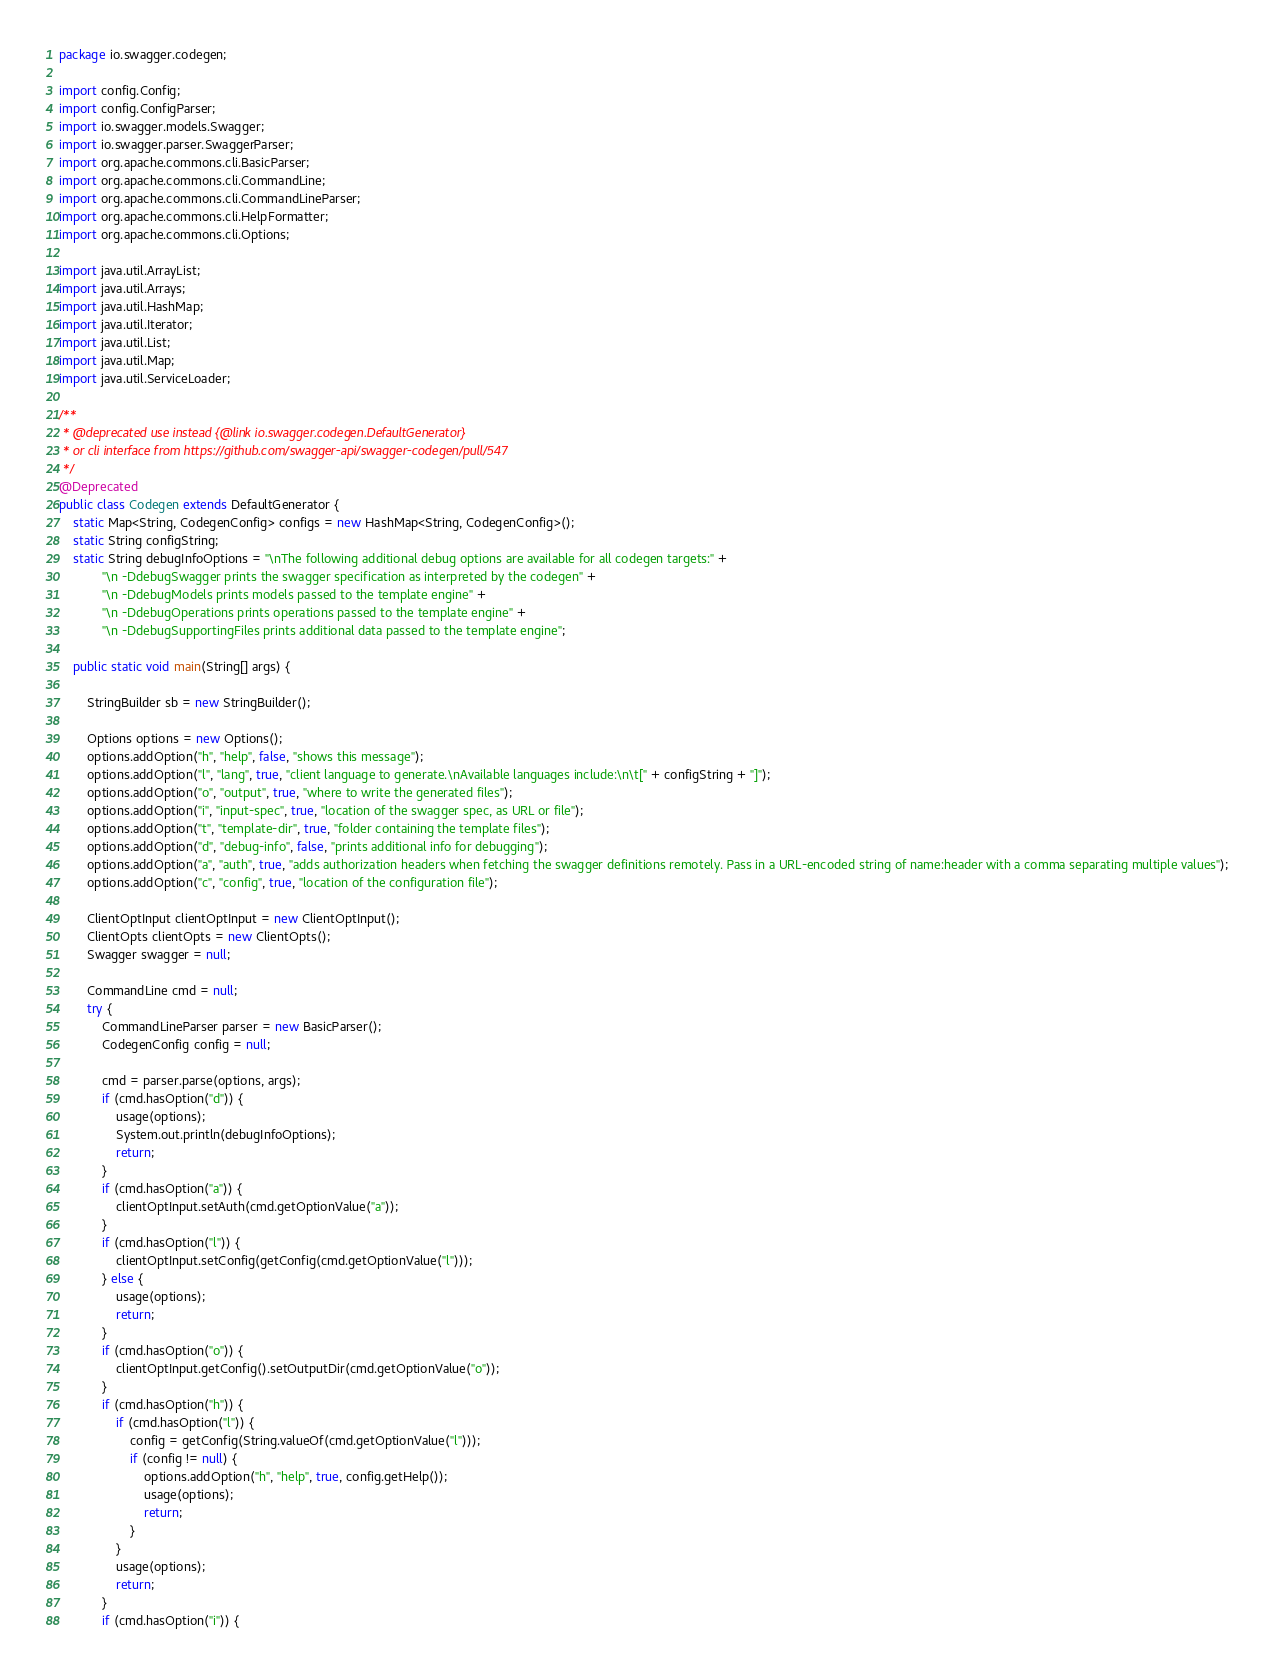Convert code to text. <code><loc_0><loc_0><loc_500><loc_500><_Java_>package io.swagger.codegen;

import config.Config;
import config.ConfigParser;
import io.swagger.models.Swagger;
import io.swagger.parser.SwaggerParser;
import org.apache.commons.cli.BasicParser;
import org.apache.commons.cli.CommandLine;
import org.apache.commons.cli.CommandLineParser;
import org.apache.commons.cli.HelpFormatter;
import org.apache.commons.cli.Options;

import java.util.ArrayList;
import java.util.Arrays;
import java.util.HashMap;
import java.util.Iterator;
import java.util.List;
import java.util.Map;
import java.util.ServiceLoader;

/**
 * @deprecated use instead {@link io.swagger.codegen.DefaultGenerator}
 * or cli interface from https://github.com/swagger-api/swagger-codegen/pull/547
 */
@Deprecated
public class Codegen extends DefaultGenerator {
    static Map<String, CodegenConfig> configs = new HashMap<String, CodegenConfig>();
    static String configString;
    static String debugInfoOptions = "\nThe following additional debug options are available for all codegen targets:" +
            "\n -DdebugSwagger prints the swagger specification as interpreted by the codegen" +
            "\n -DdebugModels prints models passed to the template engine" +
            "\n -DdebugOperations prints operations passed to the template engine" +
            "\n -DdebugSupportingFiles prints additional data passed to the template engine";

    public static void main(String[] args) {

        StringBuilder sb = new StringBuilder();

        Options options = new Options();
        options.addOption("h", "help", false, "shows this message");
        options.addOption("l", "lang", true, "client language to generate.\nAvailable languages include:\n\t[" + configString + "]");
        options.addOption("o", "output", true, "where to write the generated files");
        options.addOption("i", "input-spec", true, "location of the swagger spec, as URL or file");
        options.addOption("t", "template-dir", true, "folder containing the template files");
        options.addOption("d", "debug-info", false, "prints additional info for debugging");
        options.addOption("a", "auth", true, "adds authorization headers when fetching the swagger definitions remotely. Pass in a URL-encoded string of name:header with a comma separating multiple values");
        options.addOption("c", "config", true, "location of the configuration file");

        ClientOptInput clientOptInput = new ClientOptInput();
        ClientOpts clientOpts = new ClientOpts();
        Swagger swagger = null;

        CommandLine cmd = null;
        try {
            CommandLineParser parser = new BasicParser();
            CodegenConfig config = null;

            cmd = parser.parse(options, args);
            if (cmd.hasOption("d")) {
                usage(options);
                System.out.println(debugInfoOptions);
                return;
            }
            if (cmd.hasOption("a")) {
                clientOptInput.setAuth(cmd.getOptionValue("a"));
            }
            if (cmd.hasOption("l")) {
                clientOptInput.setConfig(getConfig(cmd.getOptionValue("l")));
            } else {
                usage(options);
                return;
            }
            if (cmd.hasOption("o")) {
                clientOptInput.getConfig().setOutputDir(cmd.getOptionValue("o"));
            }
            if (cmd.hasOption("h")) {
                if (cmd.hasOption("l")) {
                    config = getConfig(String.valueOf(cmd.getOptionValue("l")));
                    if (config != null) {
                        options.addOption("h", "help", true, config.getHelp());
                        usage(options);
                        return;
                    }
                }
                usage(options);
                return;
            }
            if (cmd.hasOption("i")) {</code> 